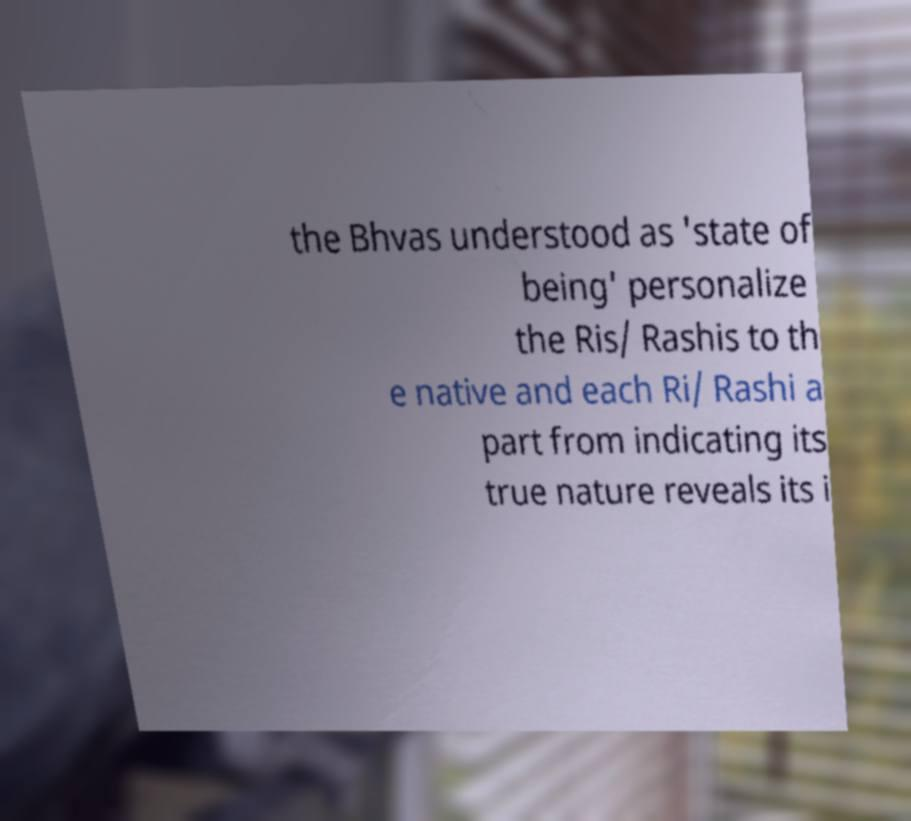Can you read and provide the text displayed in the image?This photo seems to have some interesting text. Can you extract and type it out for me? the Bhvas understood as 'state of being' personalize the Ris/ Rashis to th e native and each Ri/ Rashi a part from indicating its true nature reveals its i 